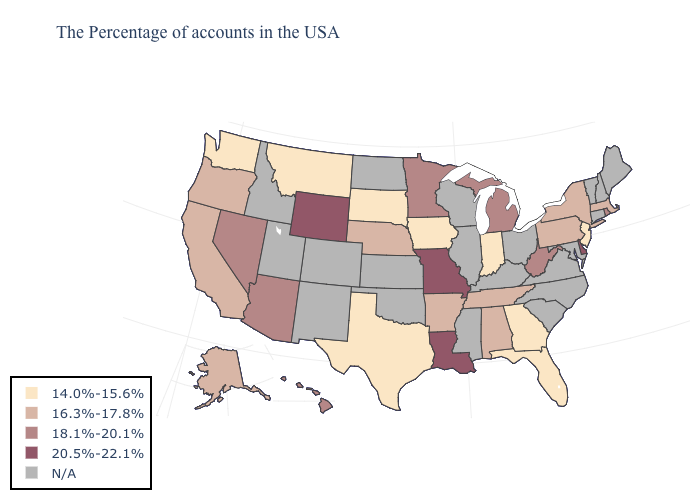Which states have the highest value in the USA?
Short answer required. Delaware, Louisiana, Missouri, Wyoming. How many symbols are there in the legend?
Concise answer only. 5. Name the states that have a value in the range 14.0%-15.6%?
Short answer required. New Jersey, Florida, Georgia, Indiana, Iowa, Texas, South Dakota, Montana, Washington. What is the lowest value in states that border California?
Write a very short answer. 16.3%-17.8%. What is the value of Iowa?
Be succinct. 14.0%-15.6%. What is the lowest value in states that border Arkansas?
Write a very short answer. 14.0%-15.6%. What is the value of Florida?
Quick response, please. 14.0%-15.6%. Does the map have missing data?
Keep it brief. Yes. Name the states that have a value in the range 20.5%-22.1%?
Answer briefly. Delaware, Louisiana, Missouri, Wyoming. Which states hav the highest value in the West?
Concise answer only. Wyoming. What is the highest value in states that border Connecticut?
Concise answer only. 18.1%-20.1%. Among the states that border Texas , which have the lowest value?
Concise answer only. Arkansas. What is the value of Pennsylvania?
Answer briefly. 16.3%-17.8%. 